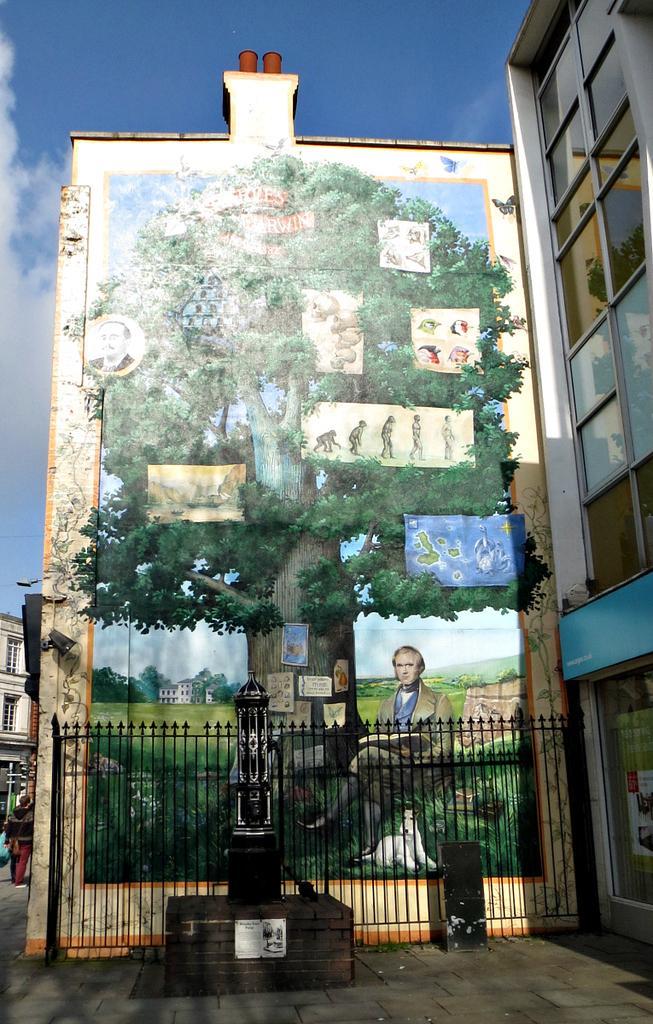Describe this image in one or two sentences. In this image I can see few buildings,glass windows,statue and fencing. I can see a painting of the person,dog,tree and few objects on the wall. The sky is in white and blue color. 